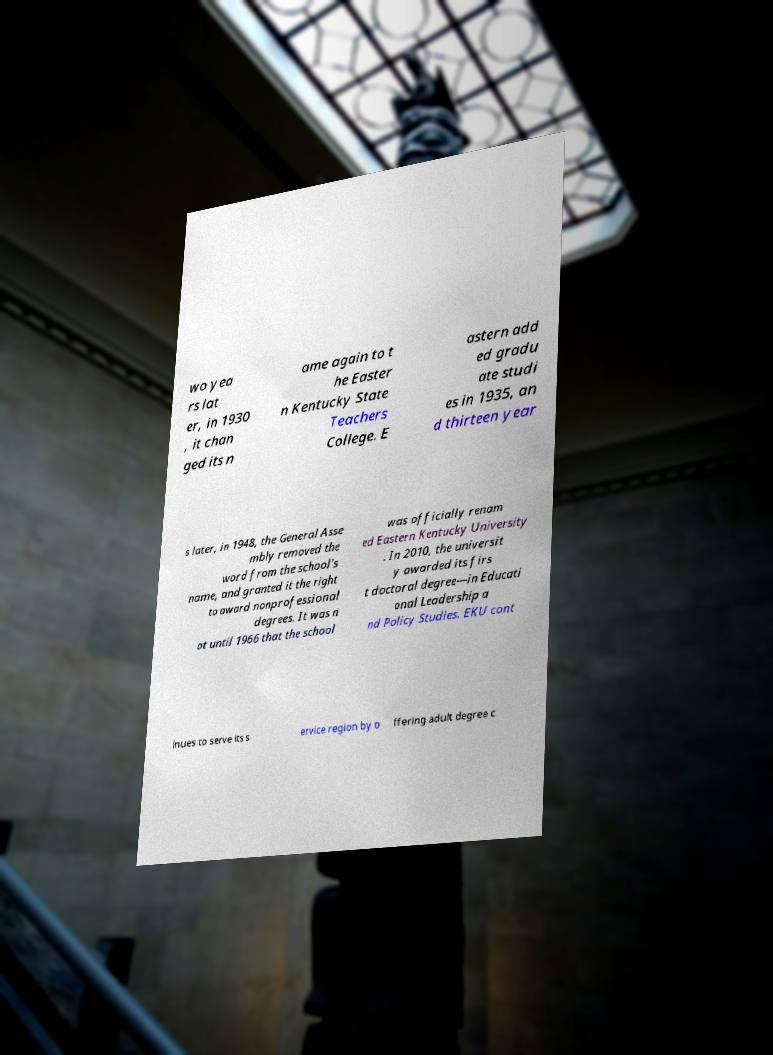Could you extract and type out the text from this image? wo yea rs lat er, in 1930 , it chan ged its n ame again to t he Easter n Kentucky State Teachers College. E astern add ed gradu ate studi es in 1935, an d thirteen year s later, in 1948, the General Asse mbly removed the word from the school's name, and granted it the right to award nonprofessional degrees. It was n ot until 1966 that the school was officially renam ed Eastern Kentucky University . In 2010, the universit y awarded its firs t doctoral degree—in Educati onal Leadership a nd Policy Studies. EKU cont inues to serve its s ervice region by o ffering adult degree c 